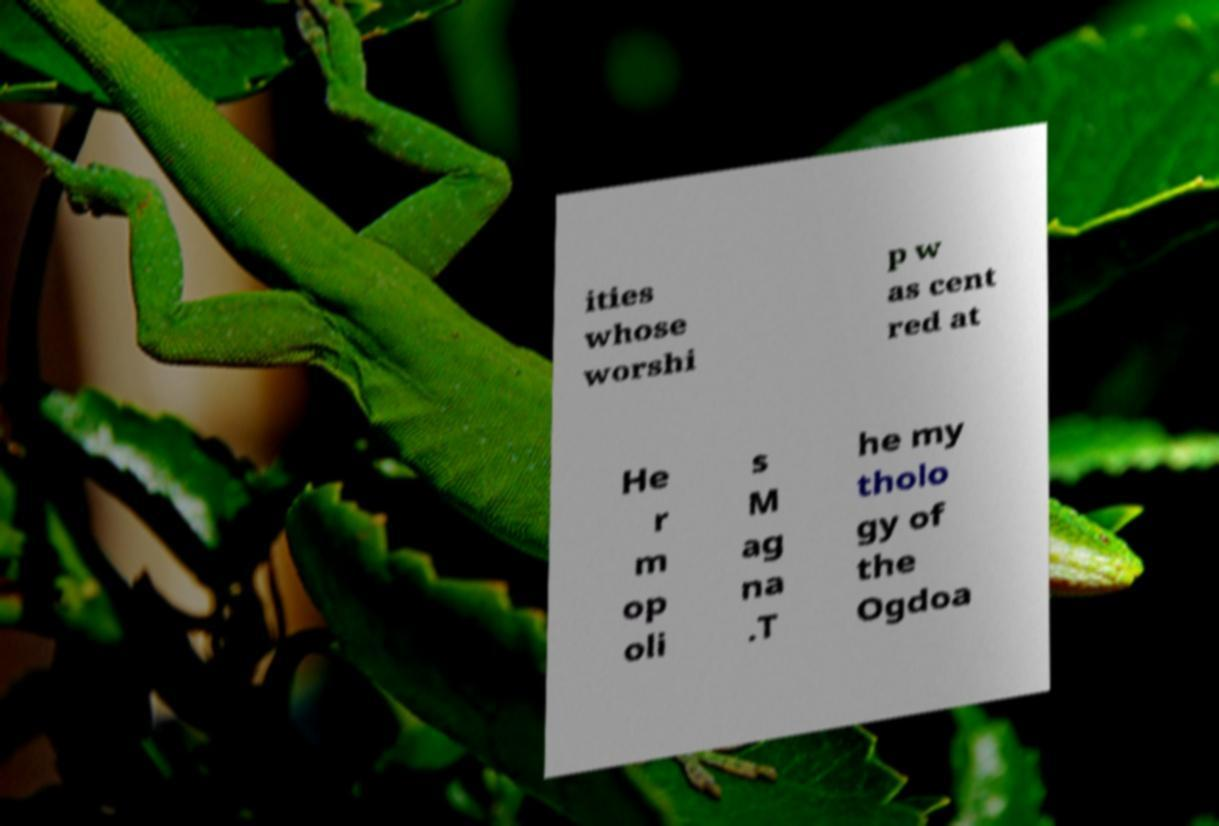Please identify and transcribe the text found in this image. ities whose worshi p w as cent red at He r m op oli s M ag na .T he my tholo gy of the Ogdoa 